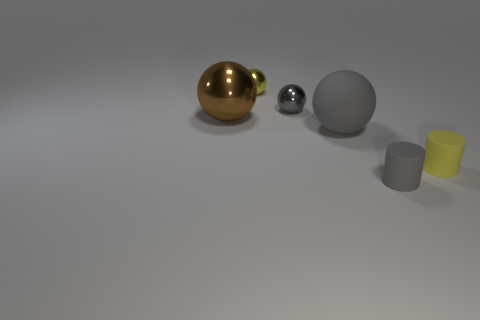Add 1 yellow balls. How many objects exist? 7 Subtract all spheres. How many objects are left? 2 Add 2 tiny yellow matte things. How many tiny yellow matte things are left? 3 Add 1 small yellow rubber things. How many small yellow rubber things exist? 2 Subtract 0 gray cubes. How many objects are left? 6 Subtract all shiny objects. Subtract all yellow matte cylinders. How many objects are left? 2 